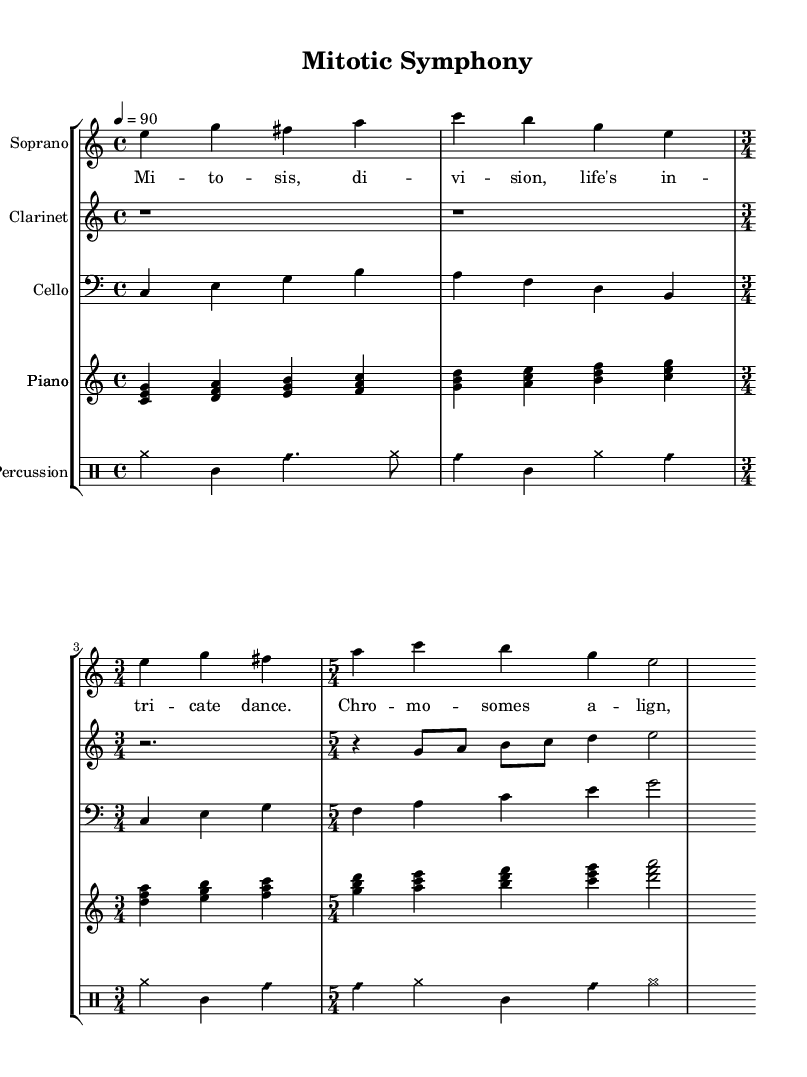What is the time signature used in the soprano part? The soprano part first shows a 4/4 time signature, then switches to 3/4, and finally to 5/4. The last time signature encountered in the part is 5/4.
Answer: 5/4 What is the tempo marking of the piece? The tempo marking is indicated at the beginning as '4 = 90', which means there are 90 beats per minute.
Answer: 90 How many instruments are featured in this score? By counting the distinct instruments listed, including soprano, clarinet, cello, piano, and percussion, there are a total of five instruments represented in the score.
Answer: Five What is the dynamic instruction for the clarinet part? The clarinet part indicates no dynamic markings, which means it may default to a mezzo-forte dynamic commonly used in operatic compositions where dynamics are contextually implied.
Answer: None In what key is the piece primarily written? The lack of a key signature and the prevalence of C major chords suggests that the piece is primarily in C major, as indicated by the notes and harmonies used throughout the score.
Answer: C major What type of vocal style is used in the soprano part? The soprano part incorporates lyrical singing with long, flowing phrases characteristic of operatic style, which is evident from the phrasing and lyrics included in the score.
Answer: Operatic 